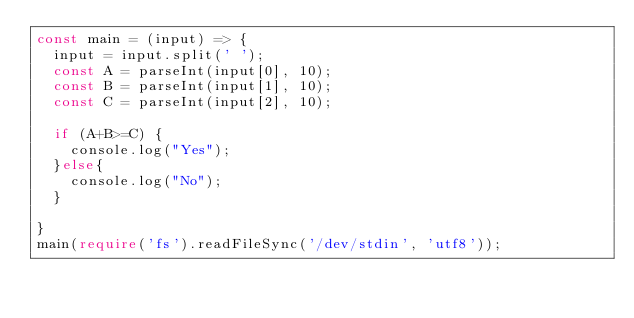Convert code to text. <code><loc_0><loc_0><loc_500><loc_500><_TypeScript_>const main = (input) => {
  input = input.split(' ');
  const A = parseInt(input[0], 10);
  const B = parseInt(input[1], 10);
  const C = parseInt(input[2], 10);
  
  if (A+B>=C) {
    console.log("Yes");
  }else{
    console.log("No");
  }
  
}
main(require('fs').readFileSync('/dev/stdin', 'utf8'));</code> 